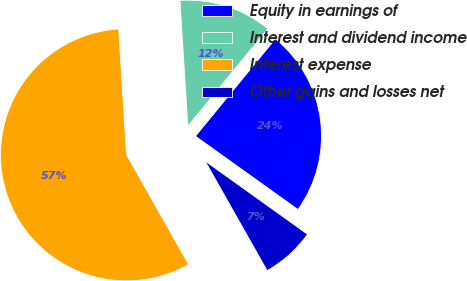<chart> <loc_0><loc_0><loc_500><loc_500><pie_chart><fcel>Equity in earnings of<fcel>Interest and dividend income<fcel>Interest expense<fcel>Other gains and losses net<nl><fcel>23.94%<fcel>11.94%<fcel>57.2%<fcel>6.92%<nl></chart> 